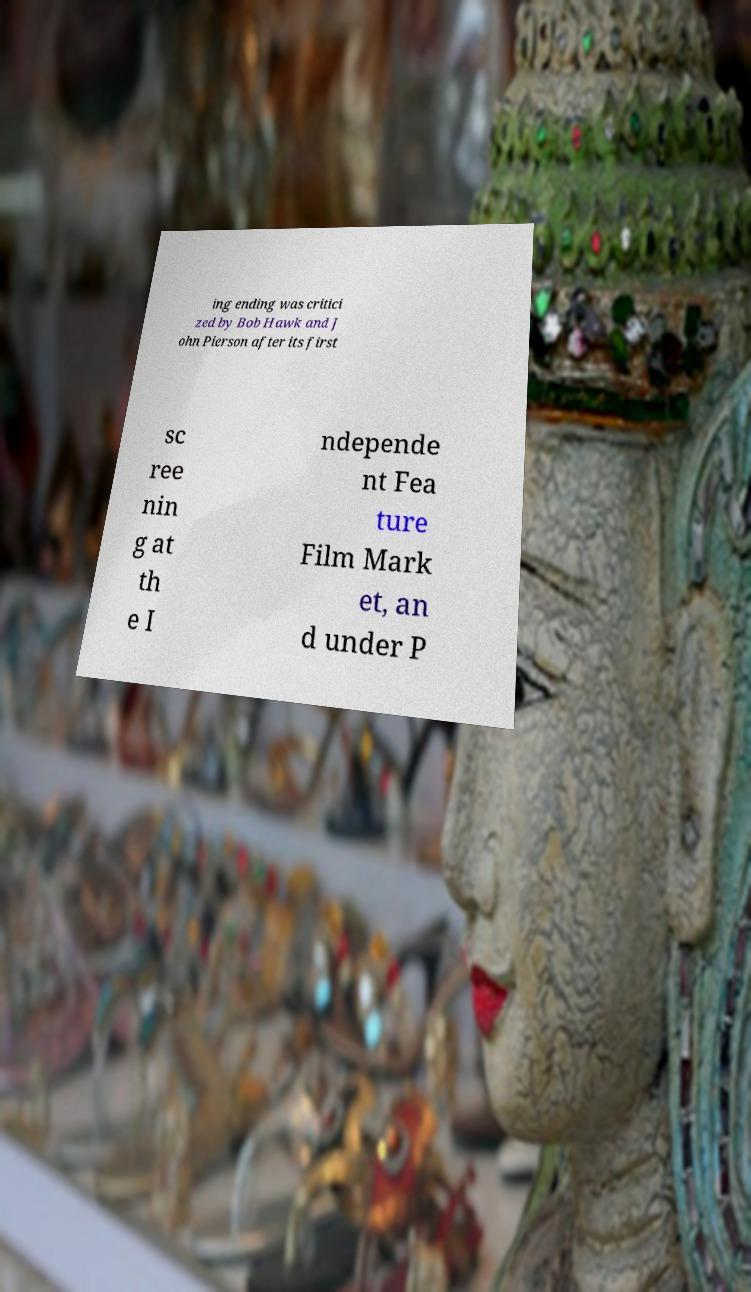Could you extract and type out the text from this image? ing ending was critici zed by Bob Hawk and J ohn Pierson after its first sc ree nin g at th e I ndepende nt Fea ture Film Mark et, an d under P 